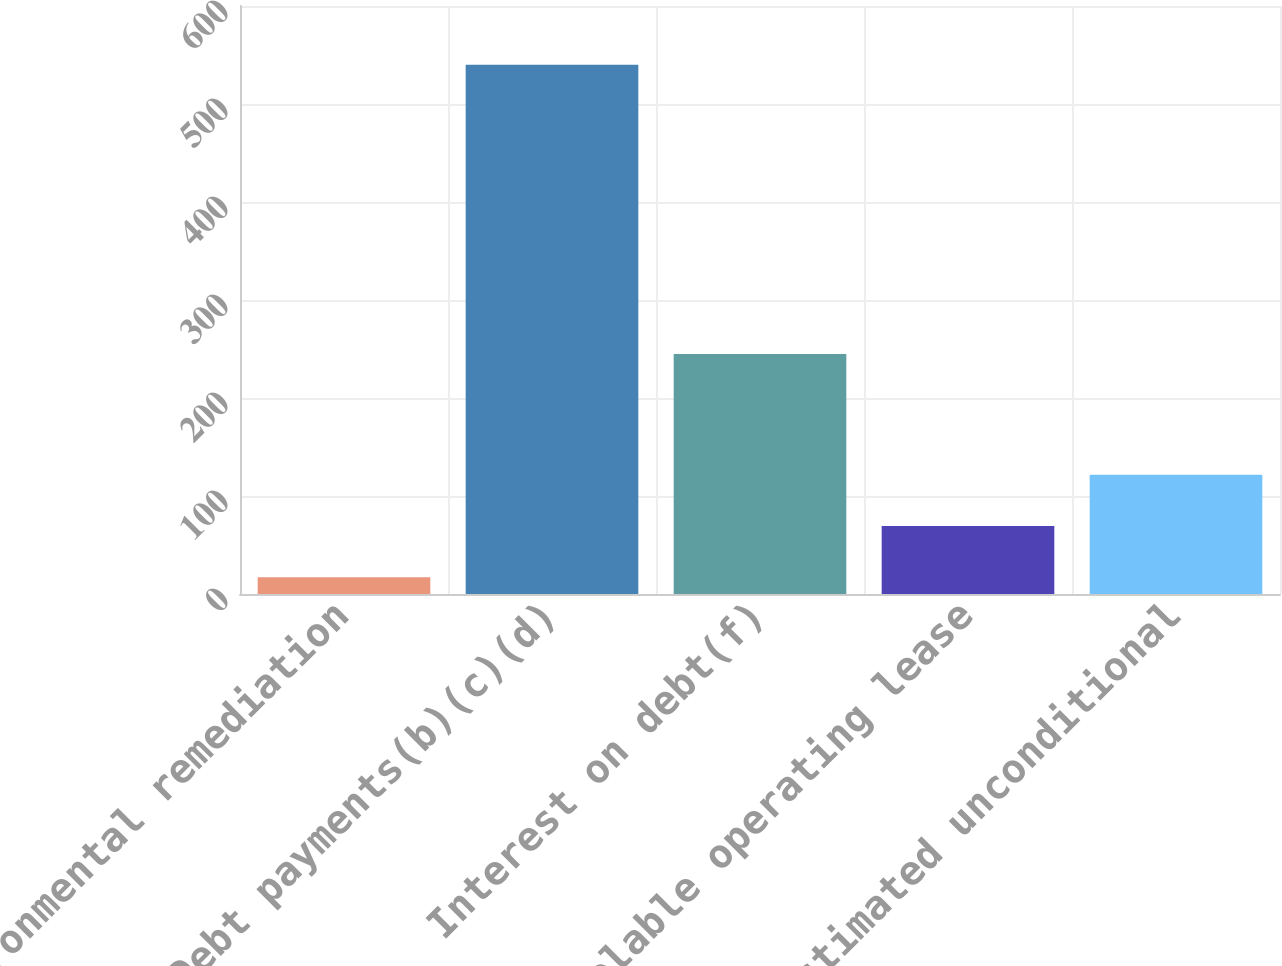<chart> <loc_0><loc_0><loc_500><loc_500><bar_chart><fcel>Environmental remediation<fcel>Debt payments(b)(c)(d)<fcel>Interest on debt(f)<fcel>Non-cancelable operating lease<fcel>Estimated unconditional<nl><fcel>17<fcel>540<fcel>245<fcel>69.3<fcel>121.6<nl></chart> 